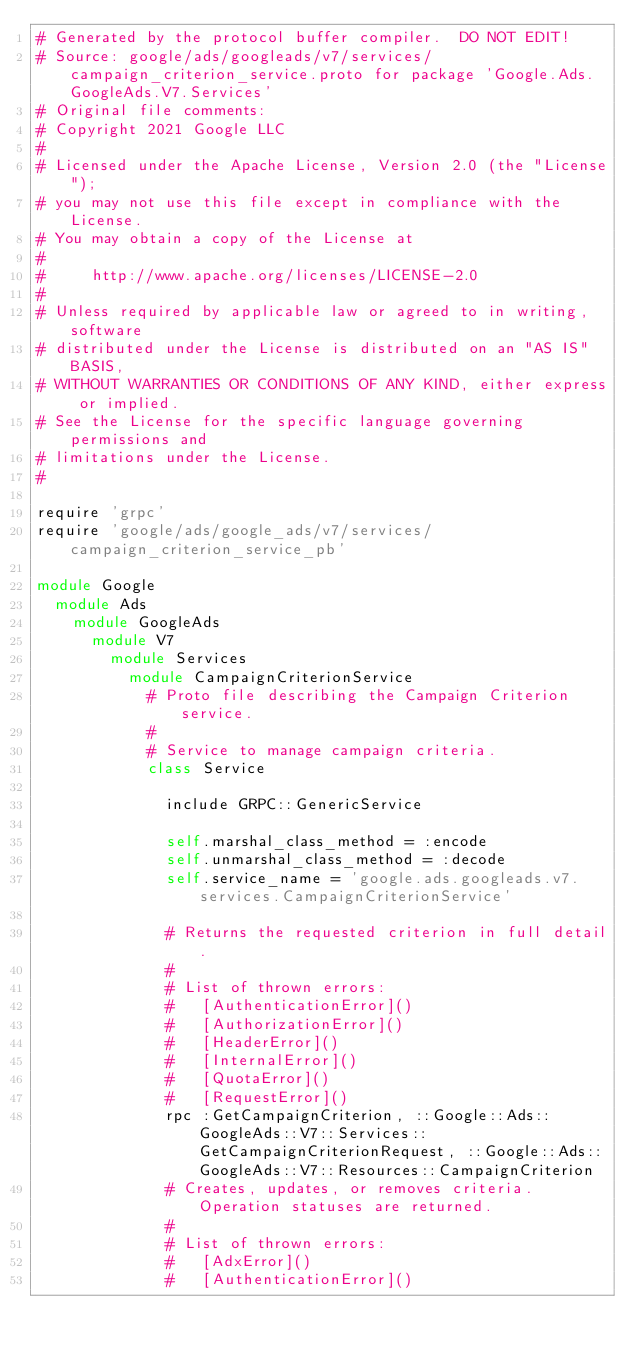<code> <loc_0><loc_0><loc_500><loc_500><_Ruby_># Generated by the protocol buffer compiler.  DO NOT EDIT!
# Source: google/ads/googleads/v7/services/campaign_criterion_service.proto for package 'Google.Ads.GoogleAds.V7.Services'
# Original file comments:
# Copyright 2021 Google LLC
#
# Licensed under the Apache License, Version 2.0 (the "License");
# you may not use this file except in compliance with the License.
# You may obtain a copy of the License at
#
#     http://www.apache.org/licenses/LICENSE-2.0
#
# Unless required by applicable law or agreed to in writing, software
# distributed under the License is distributed on an "AS IS" BASIS,
# WITHOUT WARRANTIES OR CONDITIONS OF ANY KIND, either express or implied.
# See the License for the specific language governing permissions and
# limitations under the License.
#

require 'grpc'
require 'google/ads/google_ads/v7/services/campaign_criterion_service_pb'

module Google
  module Ads
    module GoogleAds
      module V7
        module Services
          module CampaignCriterionService
            # Proto file describing the Campaign Criterion service.
            #
            # Service to manage campaign criteria.
            class Service

              include GRPC::GenericService

              self.marshal_class_method = :encode
              self.unmarshal_class_method = :decode
              self.service_name = 'google.ads.googleads.v7.services.CampaignCriterionService'

              # Returns the requested criterion in full detail.
              #
              # List of thrown errors:
              #   [AuthenticationError]()
              #   [AuthorizationError]()
              #   [HeaderError]()
              #   [InternalError]()
              #   [QuotaError]()
              #   [RequestError]()
              rpc :GetCampaignCriterion, ::Google::Ads::GoogleAds::V7::Services::GetCampaignCriterionRequest, ::Google::Ads::GoogleAds::V7::Resources::CampaignCriterion
              # Creates, updates, or removes criteria. Operation statuses are returned.
              #
              # List of thrown errors:
              #   [AdxError]()
              #   [AuthenticationError]()</code> 